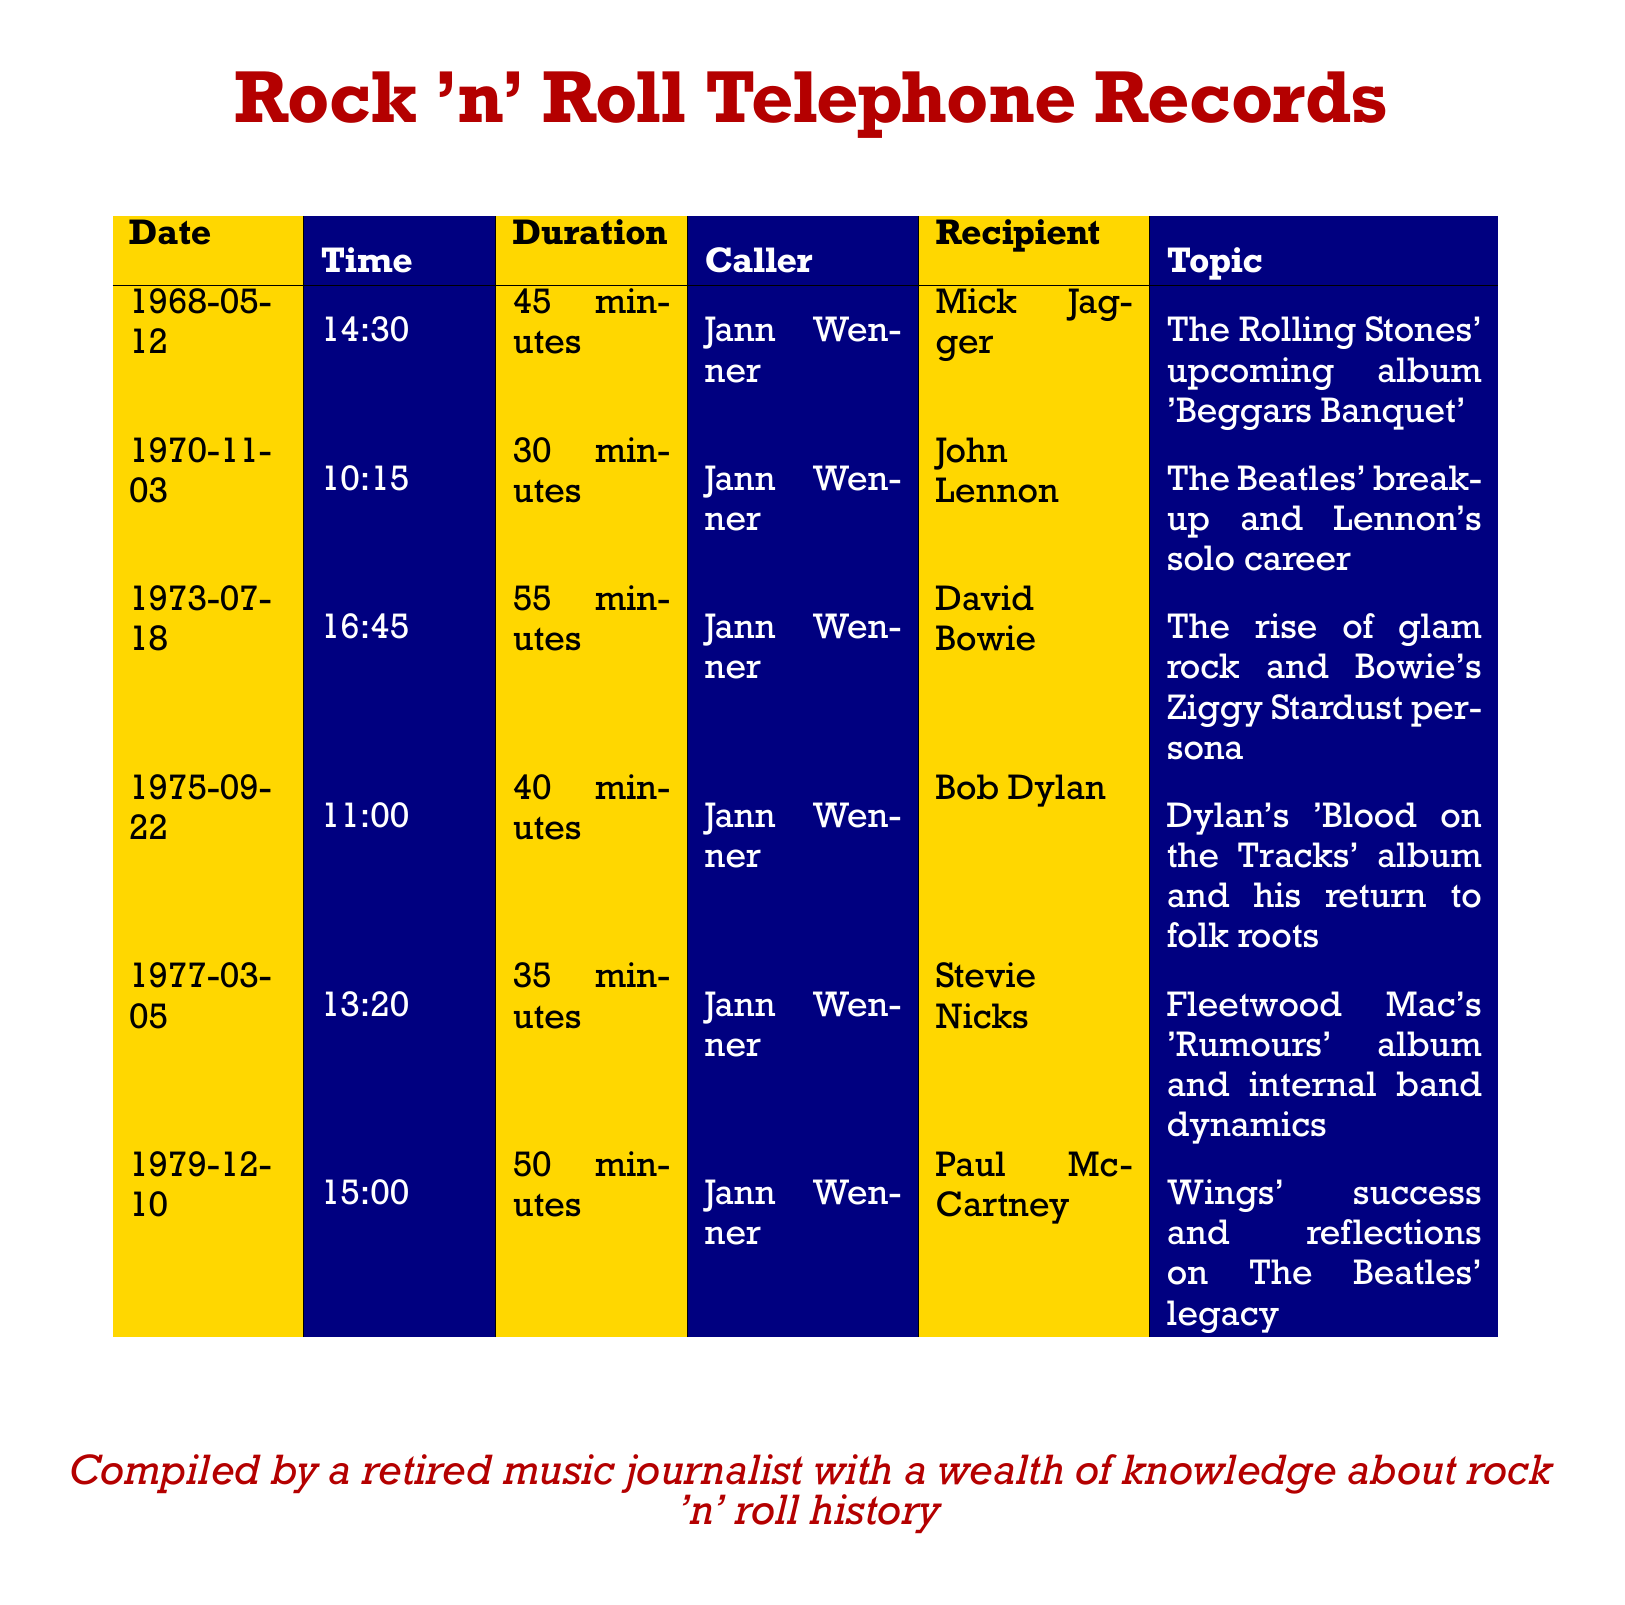What is the date of the interview with Mick Jagger? The date can be found in the call log for the interview with Mick Jagger, which is listed as May 12, 1968.
Answer: May 12, 1968 Who conducted the interview with John Lennon? The call log specifies that Jann Wenner was the caller during the interview with John Lennon.
Answer: Jann Wenner What was the duration of the call with David Bowie? The duration for the interview with David Bowie is specified as 55 minutes in the document.
Answer: 55 minutes What band was discussed in the interview with Stevie Nicks? The interview with Stevie Nicks discusses Fleetwood Mac and their album 'Rumours'.
Answer: Fleetwood Mac How many interviews are documented in total? The document lists a total of six interviews conducted, each with unique details.
Answer: 6 Which musician's solo career was mentioned in the interview on November 3, 1970? The interview on that date references John Lennon's solo career after The Beatles' break-up.
Answer: John Lennon What was the main topic discussed with Paul McCartney? The main topic for the interview with Paul McCartney revolved around Wings' success and The Beatles' legacy.
Answer: Wings' success and The Beatles' legacy Who was the recipient of the call on September 22, 1975? The recipient of the call on that date was Bob Dylan, as noted in the document.
Answer: Bob Dylan 